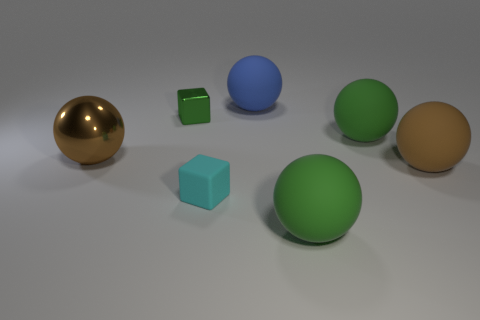Is the shape of the tiny cyan thing the same as the tiny green object?
Provide a succinct answer. Yes. There is a cyan thing that is the same size as the green cube; what is its material?
Ensure brevity in your answer.  Rubber. What is the color of the rubber cube?
Ensure brevity in your answer.  Cyan. What number of tiny things are either brown metal objects or green rubber things?
Keep it short and to the point. 0. Do the cube that is behind the brown shiny ball and the sphere that is in front of the cyan object have the same color?
Give a very brief answer. Yes. How many other objects are the same color as the big metal ball?
Provide a succinct answer. 1. There is a large green object that is behind the cyan matte thing; what shape is it?
Ensure brevity in your answer.  Sphere. Is the number of large brown shiny objects less than the number of tiny blue spheres?
Offer a very short reply. No. Is the large thing in front of the small cyan matte thing made of the same material as the small green cube?
Give a very brief answer. No. Are there any other things that have the same size as the cyan thing?
Keep it short and to the point. Yes. 